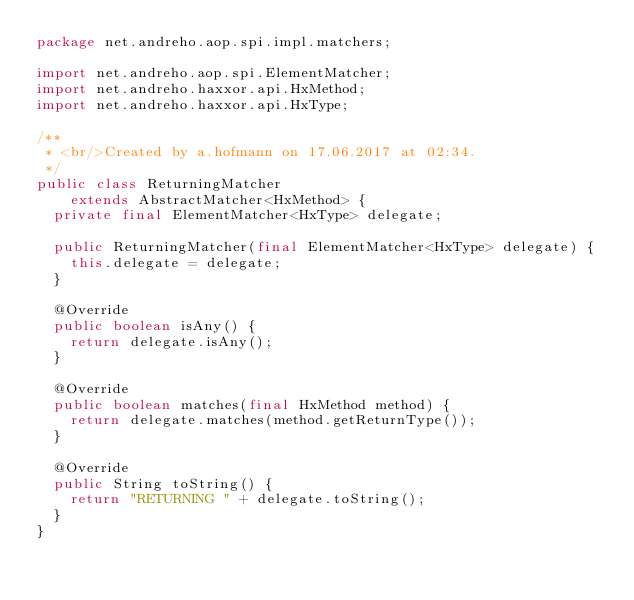Convert code to text. <code><loc_0><loc_0><loc_500><loc_500><_Java_>package net.andreho.aop.spi.impl.matchers;

import net.andreho.aop.spi.ElementMatcher;
import net.andreho.haxxor.api.HxMethod;
import net.andreho.haxxor.api.HxType;

/**
 * <br/>Created by a.hofmann on 17.06.2017 at 02:34.
 */
public class ReturningMatcher
    extends AbstractMatcher<HxMethod> {
  private final ElementMatcher<HxType> delegate;

  public ReturningMatcher(final ElementMatcher<HxType> delegate) {
    this.delegate = delegate;
  }

  @Override
  public boolean isAny() {
    return delegate.isAny();
  }

  @Override
  public boolean matches(final HxMethod method) {
    return delegate.matches(method.getReturnType());
  }

  @Override
  public String toString() {
    return "RETURNING " + delegate.toString();
  }
}
</code> 